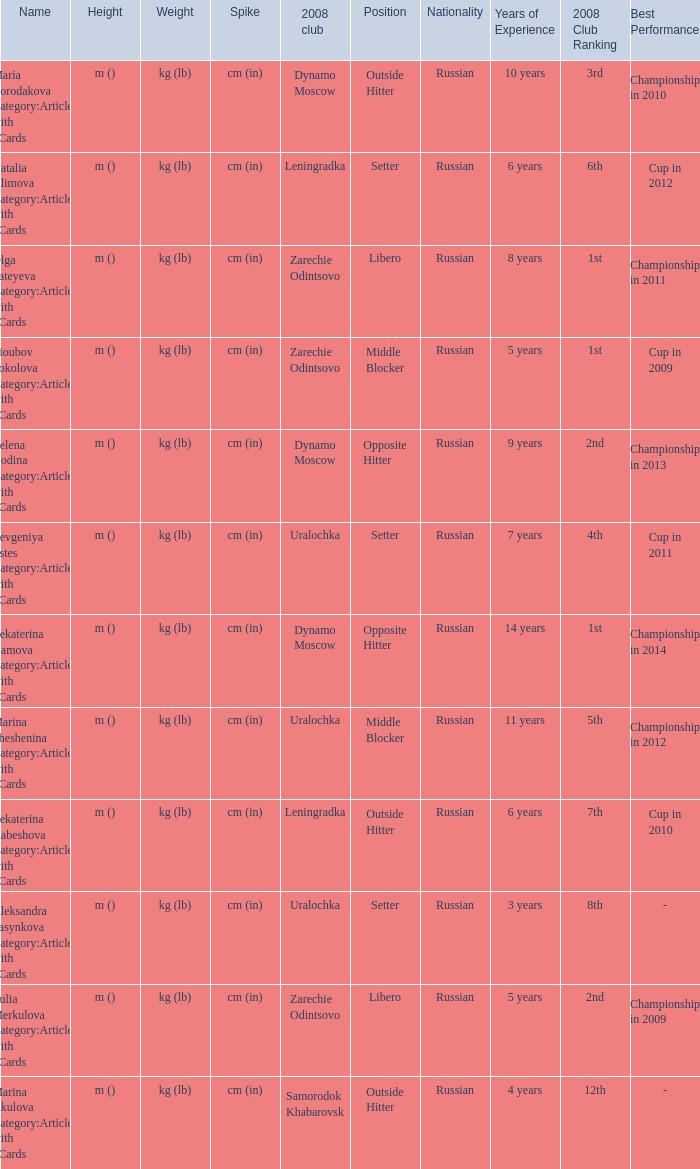What was the name of zarechie odintsovo club during 2008? Olga Fateyeva Category:Articles with hCards, Lioubov Sokolova Category:Articles with hCards, Yulia Merkulova Category:Articles with hCards. 